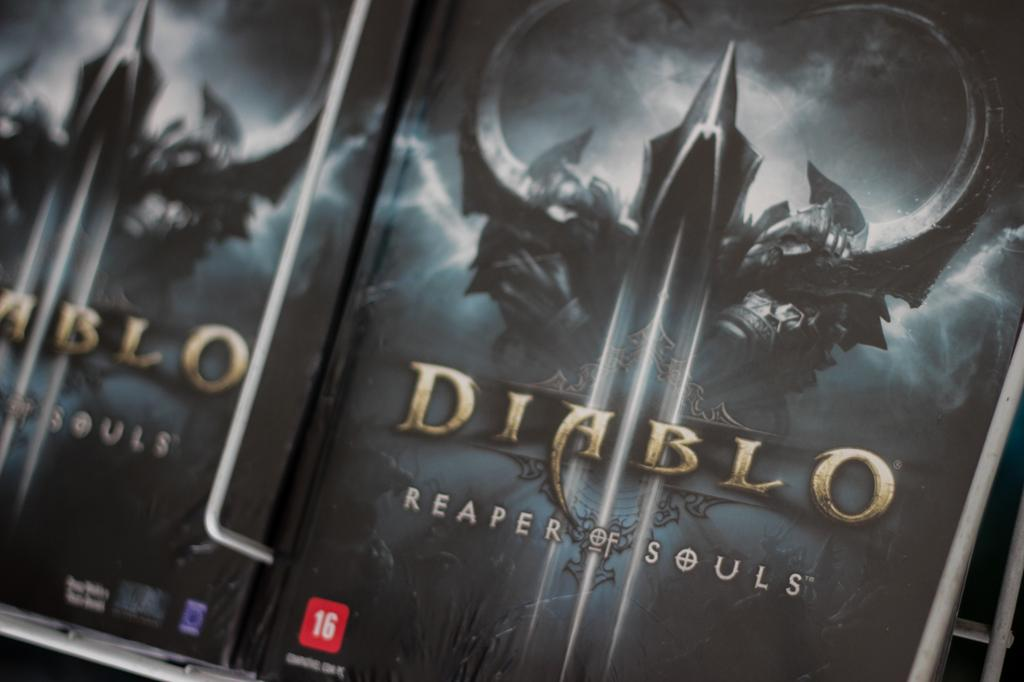<image>
Describe the image concisely. a Diablo 3 case that has art on the front 